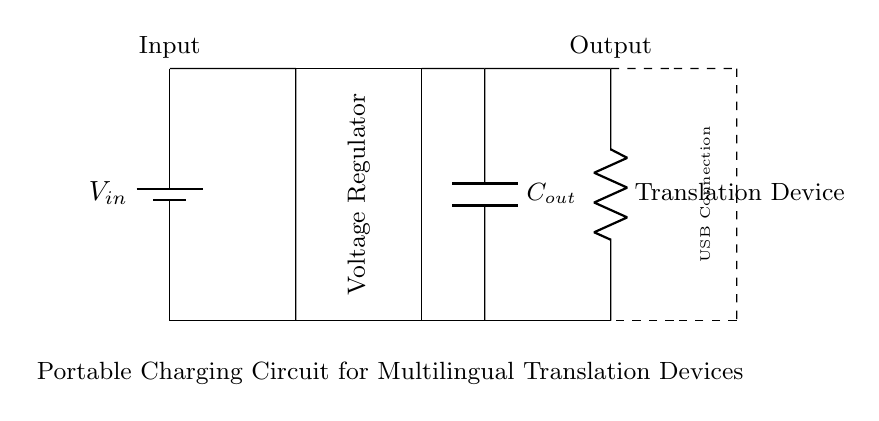What is the type of the power source in this circuit? The circuit displays a battery as the power source, indicated by the symbol used at the beginning of the diagram.
Answer: Battery What is the function of the voltage regulator? The voltage regulator ensures that the output voltage remains stable regardless of variations in the input voltage or load conditions.
Answer: Voltage regulation How many capacitors are present in this circuit? There is one capacitor shown in the circuit, specifically labeled as the output capacitor.
Answer: One What is the purpose of the output capacitor? The output capacitor smooths out the voltage fluctuating output from the regulator, providing a more stable voltage to the connected load.
Answer: Smoothing output What kind of load is connected to the circuit? The load connected is a translation device, as indicated by the label near that component in the circuit.
Answer: Translation Device What is the significance of the USB connection in this circuit? The USB connection allows for standardization in charging methods and compatibility with common electronic devices, facilitating ease of use in healthcare settings.
Answer: Standardized charging 